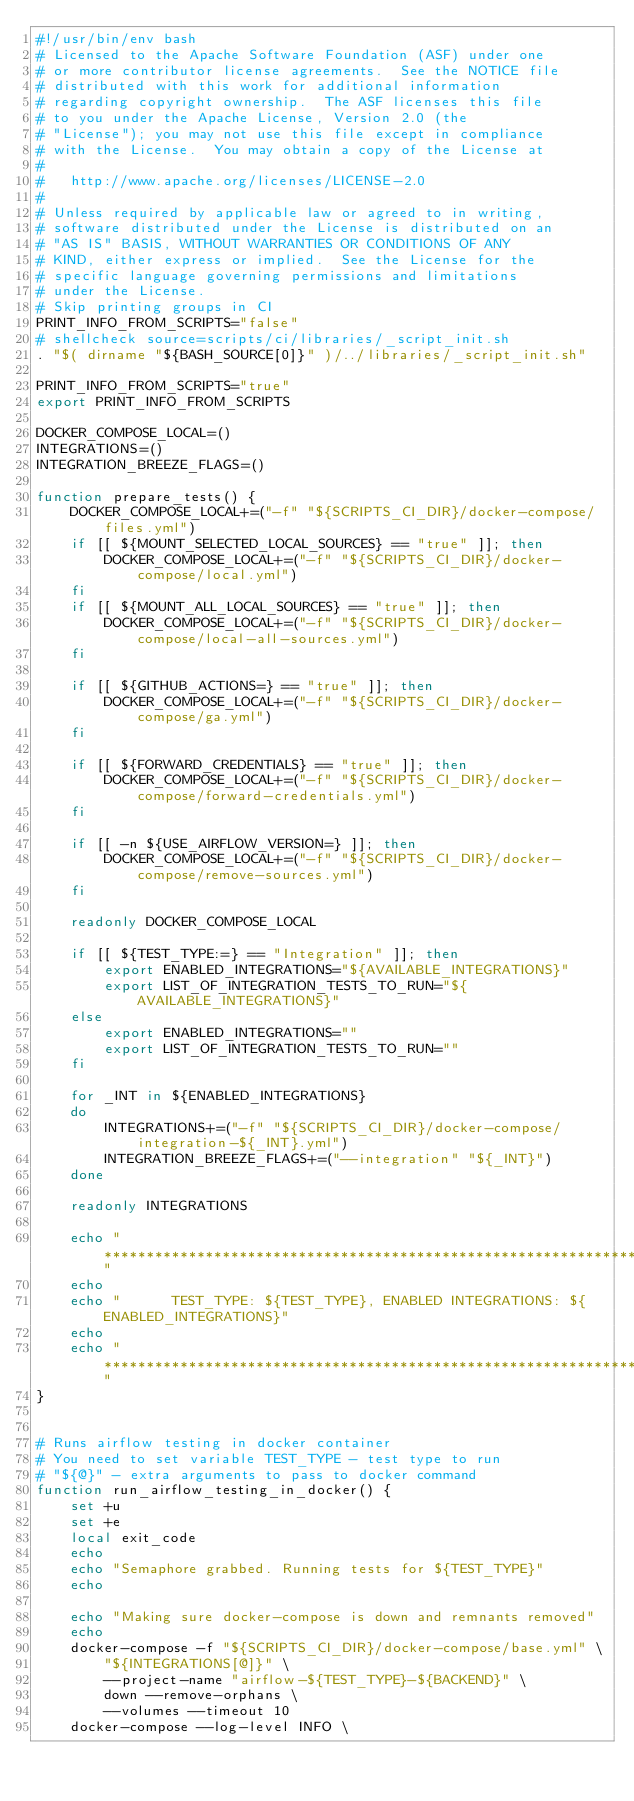Convert code to text. <code><loc_0><loc_0><loc_500><loc_500><_Bash_>#!/usr/bin/env bash
# Licensed to the Apache Software Foundation (ASF) under one
# or more contributor license agreements.  See the NOTICE file
# distributed with this work for additional information
# regarding copyright ownership.  The ASF licenses this file
# to you under the Apache License, Version 2.0 (the
# "License"); you may not use this file except in compliance
# with the License.  You may obtain a copy of the License at
#
#   http://www.apache.org/licenses/LICENSE-2.0
#
# Unless required by applicable law or agreed to in writing,
# software distributed under the License is distributed on an
# "AS IS" BASIS, WITHOUT WARRANTIES OR CONDITIONS OF ANY
# KIND, either express or implied.  See the License for the
# specific language governing permissions and limitations
# under the License.
# Skip printing groups in CI
PRINT_INFO_FROM_SCRIPTS="false"
# shellcheck source=scripts/ci/libraries/_script_init.sh
. "$( dirname "${BASH_SOURCE[0]}" )/../libraries/_script_init.sh"

PRINT_INFO_FROM_SCRIPTS="true"
export PRINT_INFO_FROM_SCRIPTS

DOCKER_COMPOSE_LOCAL=()
INTEGRATIONS=()
INTEGRATION_BREEZE_FLAGS=()

function prepare_tests() {
    DOCKER_COMPOSE_LOCAL+=("-f" "${SCRIPTS_CI_DIR}/docker-compose/files.yml")
    if [[ ${MOUNT_SELECTED_LOCAL_SOURCES} == "true" ]]; then
        DOCKER_COMPOSE_LOCAL+=("-f" "${SCRIPTS_CI_DIR}/docker-compose/local.yml")
    fi
    if [[ ${MOUNT_ALL_LOCAL_SOURCES} == "true" ]]; then
        DOCKER_COMPOSE_LOCAL+=("-f" "${SCRIPTS_CI_DIR}/docker-compose/local-all-sources.yml")
    fi

    if [[ ${GITHUB_ACTIONS=} == "true" ]]; then
        DOCKER_COMPOSE_LOCAL+=("-f" "${SCRIPTS_CI_DIR}/docker-compose/ga.yml")
    fi

    if [[ ${FORWARD_CREDENTIALS} == "true" ]]; then
        DOCKER_COMPOSE_LOCAL+=("-f" "${SCRIPTS_CI_DIR}/docker-compose/forward-credentials.yml")
    fi

    if [[ -n ${USE_AIRFLOW_VERSION=} ]]; then
        DOCKER_COMPOSE_LOCAL+=("-f" "${SCRIPTS_CI_DIR}/docker-compose/remove-sources.yml")
    fi

    readonly DOCKER_COMPOSE_LOCAL

    if [[ ${TEST_TYPE:=} == "Integration" ]]; then
        export ENABLED_INTEGRATIONS="${AVAILABLE_INTEGRATIONS}"
        export LIST_OF_INTEGRATION_TESTS_TO_RUN="${AVAILABLE_INTEGRATIONS}"
    else
        export ENABLED_INTEGRATIONS=""
        export LIST_OF_INTEGRATION_TESTS_TO_RUN=""
    fi

    for _INT in ${ENABLED_INTEGRATIONS}
    do
        INTEGRATIONS+=("-f" "${SCRIPTS_CI_DIR}/docker-compose/integration-${_INT}.yml")
        INTEGRATION_BREEZE_FLAGS+=("--integration" "${_INT}")
    done

    readonly INTEGRATIONS

    echo "**********************************************************************************************"
    echo
    echo "      TEST_TYPE: ${TEST_TYPE}, ENABLED INTEGRATIONS: ${ENABLED_INTEGRATIONS}"
    echo
    echo "**********************************************************************************************"
}


# Runs airflow testing in docker container
# You need to set variable TEST_TYPE - test type to run
# "${@}" - extra arguments to pass to docker command
function run_airflow_testing_in_docker() {
    set +u
    set +e
    local exit_code
    echo
    echo "Semaphore grabbed. Running tests for ${TEST_TYPE}"
    echo

    echo "Making sure docker-compose is down and remnants removed"
    echo
    docker-compose -f "${SCRIPTS_CI_DIR}/docker-compose/base.yml" \
        "${INTEGRATIONS[@]}" \
        --project-name "airflow-${TEST_TYPE}-${BACKEND}" \
        down --remove-orphans \
        --volumes --timeout 10
    docker-compose --log-level INFO \</code> 